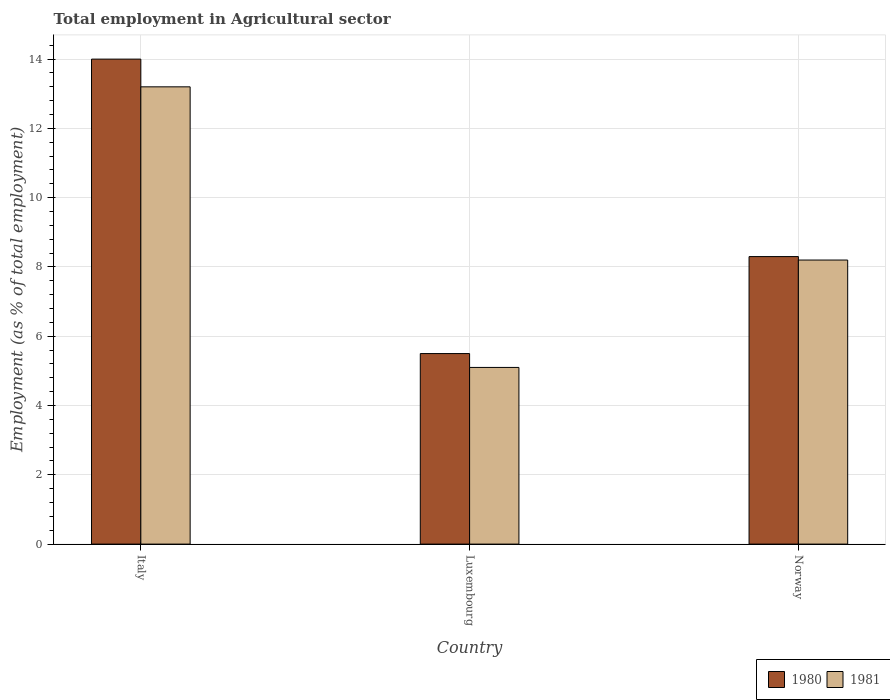How many different coloured bars are there?
Provide a short and direct response. 2. What is the label of the 3rd group of bars from the left?
Ensure brevity in your answer.  Norway. In how many cases, is the number of bars for a given country not equal to the number of legend labels?
Provide a succinct answer. 0. What is the employment in agricultural sector in 1980 in Norway?
Your answer should be compact. 8.3. Across all countries, what is the maximum employment in agricultural sector in 1980?
Your response must be concise. 14. Across all countries, what is the minimum employment in agricultural sector in 1981?
Your answer should be very brief. 5.1. In which country was the employment in agricultural sector in 1981 maximum?
Keep it short and to the point. Italy. In which country was the employment in agricultural sector in 1981 minimum?
Provide a succinct answer. Luxembourg. What is the total employment in agricultural sector in 1980 in the graph?
Provide a short and direct response. 27.8. What is the difference between the employment in agricultural sector in 1981 in Luxembourg and that in Norway?
Your answer should be very brief. -3.1. What is the difference between the employment in agricultural sector in 1981 in Luxembourg and the employment in agricultural sector in 1980 in Italy?
Ensure brevity in your answer.  -8.9. What is the average employment in agricultural sector in 1981 per country?
Offer a very short reply. 8.83. What is the difference between the employment in agricultural sector of/in 1981 and employment in agricultural sector of/in 1980 in Italy?
Offer a very short reply. -0.8. In how many countries, is the employment in agricultural sector in 1980 greater than 0.4 %?
Make the answer very short. 3. What is the ratio of the employment in agricultural sector in 1981 in Luxembourg to that in Norway?
Give a very brief answer. 0.62. Is the employment in agricultural sector in 1981 in Italy less than that in Norway?
Your response must be concise. No. What is the difference between the highest and the second highest employment in agricultural sector in 1980?
Provide a succinct answer. 2.8. What is the difference between the highest and the lowest employment in agricultural sector in 1980?
Your response must be concise. 8.5. In how many countries, is the employment in agricultural sector in 1980 greater than the average employment in agricultural sector in 1980 taken over all countries?
Keep it short and to the point. 1. Is the sum of the employment in agricultural sector in 1980 in Italy and Norway greater than the maximum employment in agricultural sector in 1981 across all countries?
Your answer should be very brief. Yes. What does the 2nd bar from the left in Norway represents?
Ensure brevity in your answer.  1981. Are all the bars in the graph horizontal?
Provide a short and direct response. No. How many countries are there in the graph?
Your answer should be very brief. 3. What is the difference between two consecutive major ticks on the Y-axis?
Make the answer very short. 2. How many legend labels are there?
Keep it short and to the point. 2. How are the legend labels stacked?
Ensure brevity in your answer.  Horizontal. What is the title of the graph?
Your answer should be compact. Total employment in Agricultural sector. Does "1965" appear as one of the legend labels in the graph?
Ensure brevity in your answer.  No. What is the label or title of the X-axis?
Keep it short and to the point. Country. What is the label or title of the Y-axis?
Make the answer very short. Employment (as % of total employment). What is the Employment (as % of total employment) in 1981 in Italy?
Keep it short and to the point. 13.2. What is the Employment (as % of total employment) of 1981 in Luxembourg?
Provide a succinct answer. 5.1. What is the Employment (as % of total employment) in 1980 in Norway?
Provide a succinct answer. 8.3. What is the Employment (as % of total employment) of 1981 in Norway?
Your answer should be compact. 8.2. Across all countries, what is the maximum Employment (as % of total employment) in 1981?
Give a very brief answer. 13.2. Across all countries, what is the minimum Employment (as % of total employment) in 1981?
Offer a terse response. 5.1. What is the total Employment (as % of total employment) in 1980 in the graph?
Your response must be concise. 27.8. What is the total Employment (as % of total employment) of 1981 in the graph?
Provide a succinct answer. 26.5. What is the difference between the Employment (as % of total employment) of 1980 in Italy and that in Luxembourg?
Provide a short and direct response. 8.5. What is the difference between the Employment (as % of total employment) in 1981 in Italy and that in Norway?
Provide a short and direct response. 5. What is the difference between the Employment (as % of total employment) in 1981 in Luxembourg and that in Norway?
Offer a terse response. -3.1. What is the difference between the Employment (as % of total employment) in 1980 in Italy and the Employment (as % of total employment) in 1981 in Luxembourg?
Your answer should be compact. 8.9. What is the difference between the Employment (as % of total employment) of 1980 in Italy and the Employment (as % of total employment) of 1981 in Norway?
Your response must be concise. 5.8. What is the average Employment (as % of total employment) in 1980 per country?
Keep it short and to the point. 9.27. What is the average Employment (as % of total employment) of 1981 per country?
Provide a succinct answer. 8.83. What is the difference between the Employment (as % of total employment) in 1980 and Employment (as % of total employment) in 1981 in Italy?
Your answer should be very brief. 0.8. What is the difference between the Employment (as % of total employment) of 1980 and Employment (as % of total employment) of 1981 in Luxembourg?
Keep it short and to the point. 0.4. What is the ratio of the Employment (as % of total employment) in 1980 in Italy to that in Luxembourg?
Provide a short and direct response. 2.55. What is the ratio of the Employment (as % of total employment) in 1981 in Italy to that in Luxembourg?
Your answer should be compact. 2.59. What is the ratio of the Employment (as % of total employment) of 1980 in Italy to that in Norway?
Keep it short and to the point. 1.69. What is the ratio of the Employment (as % of total employment) in 1981 in Italy to that in Norway?
Your answer should be compact. 1.61. What is the ratio of the Employment (as % of total employment) in 1980 in Luxembourg to that in Norway?
Give a very brief answer. 0.66. What is the ratio of the Employment (as % of total employment) in 1981 in Luxembourg to that in Norway?
Provide a succinct answer. 0.62. What is the difference between the highest and the second highest Employment (as % of total employment) of 1980?
Ensure brevity in your answer.  5.7. 